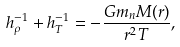<formula> <loc_0><loc_0><loc_500><loc_500>h _ { \rho } ^ { - 1 } + h _ { T } ^ { - 1 } = - \frac { G m _ { n } M ( r ) } { r ^ { 2 } T } ,</formula> 